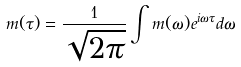<formula> <loc_0><loc_0><loc_500><loc_500>m ( \tau ) = \frac { 1 } { \sqrt { 2 \pi } } \int m ( \omega ) e ^ { i \omega \tau } d \omega</formula> 